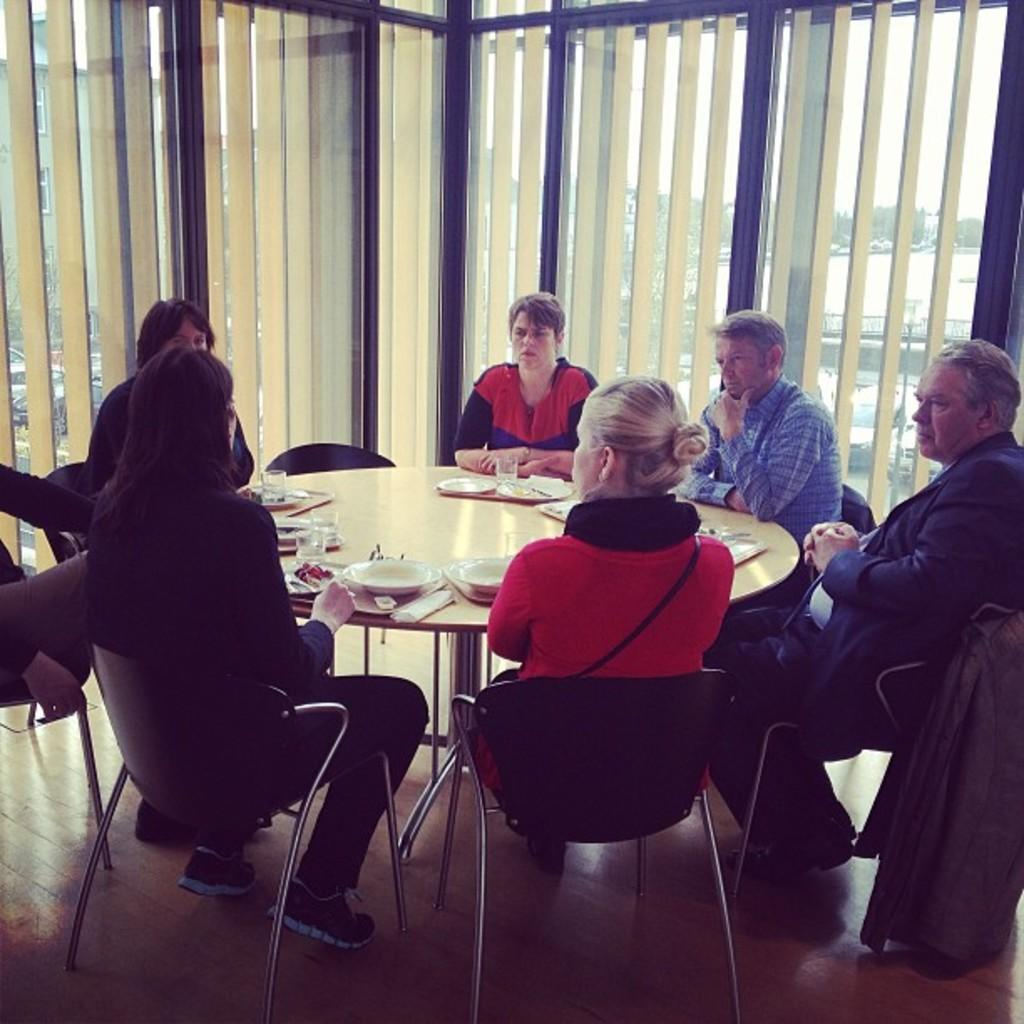What is happening in the image involving a group of people? The group of people is setting up a table. What items can be seen on the table in the image? There is a plate, napkins, forks, and spoons visible on the table. Can you describe the background of the image? There is a window in the background of the image. What rule is being enforced by the army in the image? There is no army or rule present in the image; it features a group of people setting up a table. What emotion is displayed by the people in the image due to the presence of spoons? There is no indication of emotion or disgust in the image; it simply shows a group of people setting up a table with various items. 